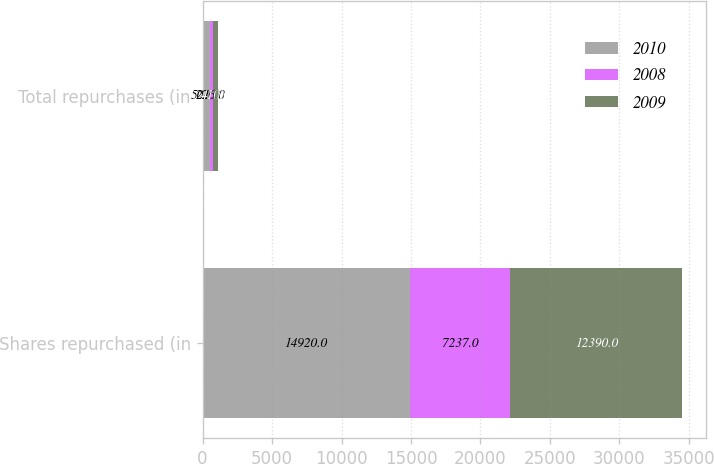Convert chart. <chart><loc_0><loc_0><loc_500><loc_500><stacked_bar_chart><ecel><fcel>Shares repurchased (in<fcel>Total repurchases (in<nl><fcel>2010<fcel>14920<fcel>501<nl><fcel>2008<fcel>7237<fcel>226<nl><fcel>2009<fcel>12390<fcel>410<nl></chart> 